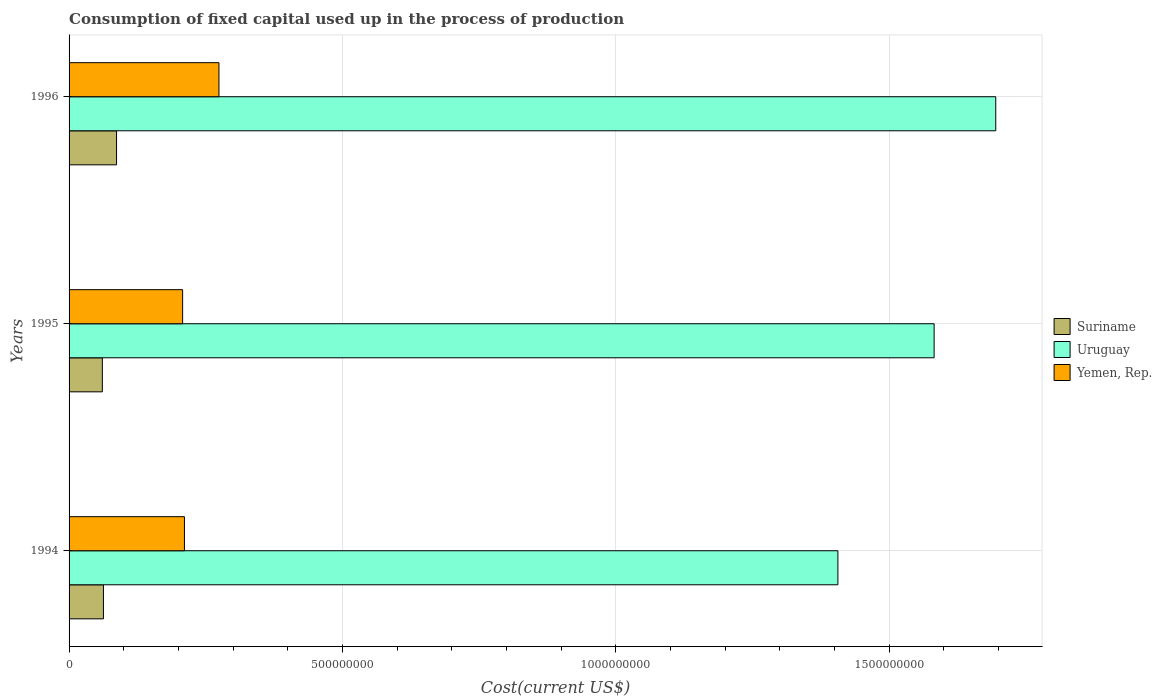How many different coloured bars are there?
Ensure brevity in your answer.  3. How many groups of bars are there?
Ensure brevity in your answer.  3. Are the number of bars on each tick of the Y-axis equal?
Provide a short and direct response. Yes. What is the label of the 3rd group of bars from the top?
Give a very brief answer. 1994. What is the amount consumed in the process of production in Yemen, Rep. in 1994?
Ensure brevity in your answer.  2.11e+08. Across all years, what is the maximum amount consumed in the process of production in Suriname?
Your answer should be compact. 8.68e+07. Across all years, what is the minimum amount consumed in the process of production in Uruguay?
Keep it short and to the point. 1.41e+09. What is the total amount consumed in the process of production in Yemen, Rep. in the graph?
Offer a terse response. 6.93e+08. What is the difference between the amount consumed in the process of production in Suriname in 1994 and that in 1995?
Provide a short and direct response. 2.01e+06. What is the difference between the amount consumed in the process of production in Yemen, Rep. in 1996 and the amount consumed in the process of production in Suriname in 1995?
Offer a terse response. 2.13e+08. What is the average amount consumed in the process of production in Suriname per year?
Give a very brief answer. 7.02e+07. In the year 1994, what is the difference between the amount consumed in the process of production in Uruguay and amount consumed in the process of production in Suriname?
Your answer should be very brief. 1.34e+09. In how many years, is the amount consumed in the process of production in Uruguay greater than 200000000 US$?
Make the answer very short. 3. What is the ratio of the amount consumed in the process of production in Uruguay in 1994 to that in 1996?
Provide a short and direct response. 0.83. Is the amount consumed in the process of production in Uruguay in 1994 less than that in 1995?
Offer a very short reply. Yes. Is the difference between the amount consumed in the process of production in Uruguay in 1995 and 1996 greater than the difference between the amount consumed in the process of production in Suriname in 1995 and 1996?
Keep it short and to the point. No. What is the difference between the highest and the second highest amount consumed in the process of production in Suriname?
Your answer should be compact. 2.39e+07. What is the difference between the highest and the lowest amount consumed in the process of production in Suriname?
Your response must be concise. 2.60e+07. Is the sum of the amount consumed in the process of production in Uruguay in 1994 and 1995 greater than the maximum amount consumed in the process of production in Suriname across all years?
Ensure brevity in your answer.  Yes. What does the 3rd bar from the top in 1996 represents?
Your answer should be compact. Suriname. What does the 3rd bar from the bottom in 1994 represents?
Make the answer very short. Yemen, Rep. Is it the case that in every year, the sum of the amount consumed in the process of production in Yemen, Rep. and amount consumed in the process of production in Uruguay is greater than the amount consumed in the process of production in Suriname?
Offer a terse response. Yes. How many years are there in the graph?
Your answer should be very brief. 3. What is the difference between two consecutive major ticks on the X-axis?
Offer a terse response. 5.00e+08. Does the graph contain any zero values?
Ensure brevity in your answer.  No. Does the graph contain grids?
Provide a short and direct response. Yes. How are the legend labels stacked?
Provide a short and direct response. Vertical. What is the title of the graph?
Your answer should be compact. Consumption of fixed capital used up in the process of production. Does "Bulgaria" appear as one of the legend labels in the graph?
Your answer should be compact. No. What is the label or title of the X-axis?
Your answer should be very brief. Cost(current US$). What is the label or title of the Y-axis?
Make the answer very short. Years. What is the Cost(current US$) of Suriname in 1994?
Keep it short and to the point. 6.29e+07. What is the Cost(current US$) of Uruguay in 1994?
Your response must be concise. 1.41e+09. What is the Cost(current US$) of Yemen, Rep. in 1994?
Give a very brief answer. 2.11e+08. What is the Cost(current US$) of Suriname in 1995?
Keep it short and to the point. 6.09e+07. What is the Cost(current US$) of Uruguay in 1995?
Ensure brevity in your answer.  1.58e+09. What is the Cost(current US$) of Yemen, Rep. in 1995?
Your response must be concise. 2.08e+08. What is the Cost(current US$) in Suriname in 1996?
Make the answer very short. 8.68e+07. What is the Cost(current US$) of Uruguay in 1996?
Offer a very short reply. 1.69e+09. What is the Cost(current US$) in Yemen, Rep. in 1996?
Provide a succinct answer. 2.74e+08. Across all years, what is the maximum Cost(current US$) in Suriname?
Make the answer very short. 8.68e+07. Across all years, what is the maximum Cost(current US$) of Uruguay?
Your answer should be compact. 1.69e+09. Across all years, what is the maximum Cost(current US$) of Yemen, Rep.?
Provide a short and direct response. 2.74e+08. Across all years, what is the minimum Cost(current US$) of Suriname?
Your answer should be compact. 6.09e+07. Across all years, what is the minimum Cost(current US$) in Uruguay?
Provide a short and direct response. 1.41e+09. Across all years, what is the minimum Cost(current US$) in Yemen, Rep.?
Keep it short and to the point. 2.08e+08. What is the total Cost(current US$) of Suriname in the graph?
Keep it short and to the point. 2.11e+08. What is the total Cost(current US$) of Uruguay in the graph?
Your answer should be compact. 4.68e+09. What is the total Cost(current US$) in Yemen, Rep. in the graph?
Provide a succinct answer. 6.93e+08. What is the difference between the Cost(current US$) in Suriname in 1994 and that in 1995?
Make the answer very short. 2.01e+06. What is the difference between the Cost(current US$) of Uruguay in 1994 and that in 1995?
Offer a very short reply. -1.76e+08. What is the difference between the Cost(current US$) of Yemen, Rep. in 1994 and that in 1995?
Your answer should be very brief. 3.30e+06. What is the difference between the Cost(current US$) of Suriname in 1994 and that in 1996?
Provide a short and direct response. -2.39e+07. What is the difference between the Cost(current US$) in Uruguay in 1994 and that in 1996?
Provide a succinct answer. -2.89e+08. What is the difference between the Cost(current US$) of Yemen, Rep. in 1994 and that in 1996?
Offer a terse response. -6.31e+07. What is the difference between the Cost(current US$) in Suriname in 1995 and that in 1996?
Offer a very short reply. -2.60e+07. What is the difference between the Cost(current US$) in Uruguay in 1995 and that in 1996?
Provide a short and direct response. -1.13e+08. What is the difference between the Cost(current US$) in Yemen, Rep. in 1995 and that in 1996?
Keep it short and to the point. -6.64e+07. What is the difference between the Cost(current US$) of Suriname in 1994 and the Cost(current US$) of Uruguay in 1995?
Keep it short and to the point. -1.52e+09. What is the difference between the Cost(current US$) in Suriname in 1994 and the Cost(current US$) in Yemen, Rep. in 1995?
Make the answer very short. -1.45e+08. What is the difference between the Cost(current US$) of Uruguay in 1994 and the Cost(current US$) of Yemen, Rep. in 1995?
Provide a succinct answer. 1.20e+09. What is the difference between the Cost(current US$) in Suriname in 1994 and the Cost(current US$) in Uruguay in 1996?
Provide a short and direct response. -1.63e+09. What is the difference between the Cost(current US$) in Suriname in 1994 and the Cost(current US$) in Yemen, Rep. in 1996?
Ensure brevity in your answer.  -2.11e+08. What is the difference between the Cost(current US$) of Uruguay in 1994 and the Cost(current US$) of Yemen, Rep. in 1996?
Provide a short and direct response. 1.13e+09. What is the difference between the Cost(current US$) in Suriname in 1995 and the Cost(current US$) in Uruguay in 1996?
Make the answer very short. -1.63e+09. What is the difference between the Cost(current US$) in Suriname in 1995 and the Cost(current US$) in Yemen, Rep. in 1996?
Your answer should be compact. -2.13e+08. What is the difference between the Cost(current US$) in Uruguay in 1995 and the Cost(current US$) in Yemen, Rep. in 1996?
Ensure brevity in your answer.  1.31e+09. What is the average Cost(current US$) of Suriname per year?
Make the answer very short. 7.02e+07. What is the average Cost(current US$) of Uruguay per year?
Your response must be concise. 1.56e+09. What is the average Cost(current US$) of Yemen, Rep. per year?
Your answer should be very brief. 2.31e+08. In the year 1994, what is the difference between the Cost(current US$) in Suriname and Cost(current US$) in Uruguay?
Your answer should be very brief. -1.34e+09. In the year 1994, what is the difference between the Cost(current US$) in Suriname and Cost(current US$) in Yemen, Rep.?
Your answer should be compact. -1.48e+08. In the year 1994, what is the difference between the Cost(current US$) of Uruguay and Cost(current US$) of Yemen, Rep.?
Ensure brevity in your answer.  1.20e+09. In the year 1995, what is the difference between the Cost(current US$) of Suriname and Cost(current US$) of Uruguay?
Your answer should be very brief. -1.52e+09. In the year 1995, what is the difference between the Cost(current US$) in Suriname and Cost(current US$) in Yemen, Rep.?
Ensure brevity in your answer.  -1.47e+08. In the year 1995, what is the difference between the Cost(current US$) in Uruguay and Cost(current US$) in Yemen, Rep.?
Your response must be concise. 1.37e+09. In the year 1996, what is the difference between the Cost(current US$) in Suriname and Cost(current US$) in Uruguay?
Offer a very short reply. -1.61e+09. In the year 1996, what is the difference between the Cost(current US$) in Suriname and Cost(current US$) in Yemen, Rep.?
Offer a terse response. -1.87e+08. In the year 1996, what is the difference between the Cost(current US$) of Uruguay and Cost(current US$) of Yemen, Rep.?
Your response must be concise. 1.42e+09. What is the ratio of the Cost(current US$) of Suriname in 1994 to that in 1995?
Your answer should be compact. 1.03. What is the ratio of the Cost(current US$) in Uruguay in 1994 to that in 1995?
Give a very brief answer. 0.89. What is the ratio of the Cost(current US$) of Yemen, Rep. in 1994 to that in 1995?
Provide a succinct answer. 1.02. What is the ratio of the Cost(current US$) in Suriname in 1994 to that in 1996?
Your answer should be compact. 0.72. What is the ratio of the Cost(current US$) of Uruguay in 1994 to that in 1996?
Provide a succinct answer. 0.83. What is the ratio of the Cost(current US$) of Yemen, Rep. in 1994 to that in 1996?
Provide a succinct answer. 0.77. What is the ratio of the Cost(current US$) in Suriname in 1995 to that in 1996?
Keep it short and to the point. 0.7. What is the ratio of the Cost(current US$) of Uruguay in 1995 to that in 1996?
Make the answer very short. 0.93. What is the ratio of the Cost(current US$) in Yemen, Rep. in 1995 to that in 1996?
Offer a terse response. 0.76. What is the difference between the highest and the second highest Cost(current US$) of Suriname?
Provide a succinct answer. 2.39e+07. What is the difference between the highest and the second highest Cost(current US$) in Uruguay?
Your response must be concise. 1.13e+08. What is the difference between the highest and the second highest Cost(current US$) in Yemen, Rep.?
Make the answer very short. 6.31e+07. What is the difference between the highest and the lowest Cost(current US$) of Suriname?
Your answer should be compact. 2.60e+07. What is the difference between the highest and the lowest Cost(current US$) of Uruguay?
Your answer should be very brief. 2.89e+08. What is the difference between the highest and the lowest Cost(current US$) of Yemen, Rep.?
Your answer should be compact. 6.64e+07. 